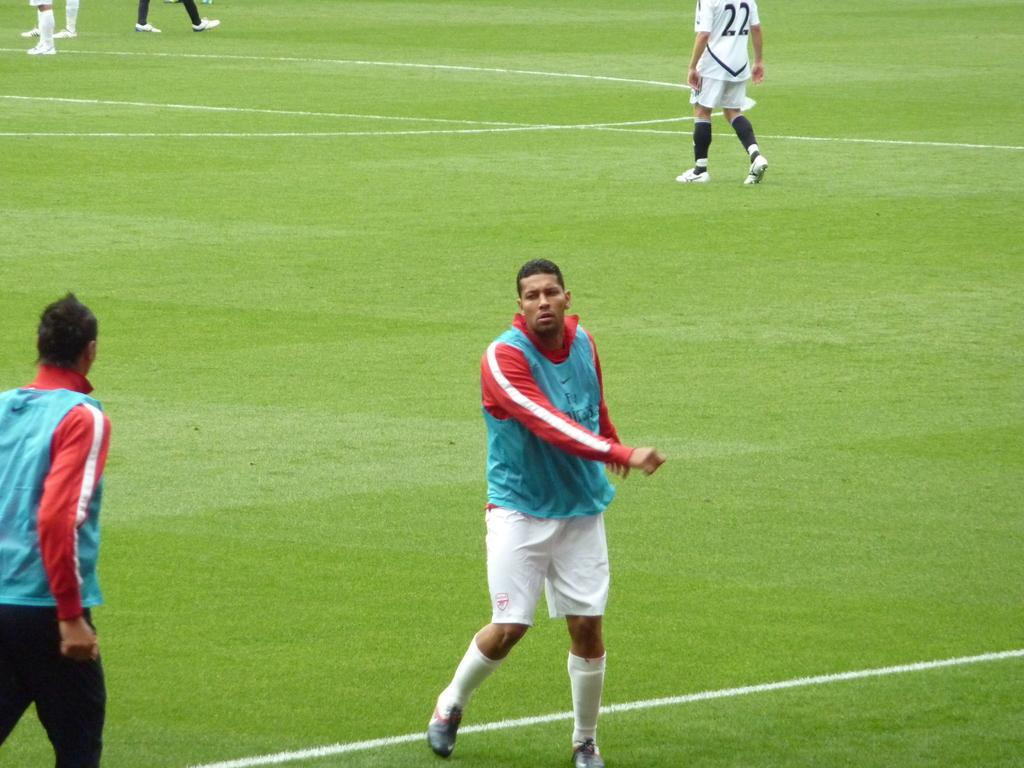What type of surface is visible in the image? There is green grass in the image. Are there any markings on the grass? Yes, there are white lines on the grass. What else can be seen in the image? There are people in the image. What are the people wearing? The people are wearing jerseys. Can you describe the jerseys? The jerseys are colorful. What verse is being recited by the son in the image? There is no son or verse present in the image. 